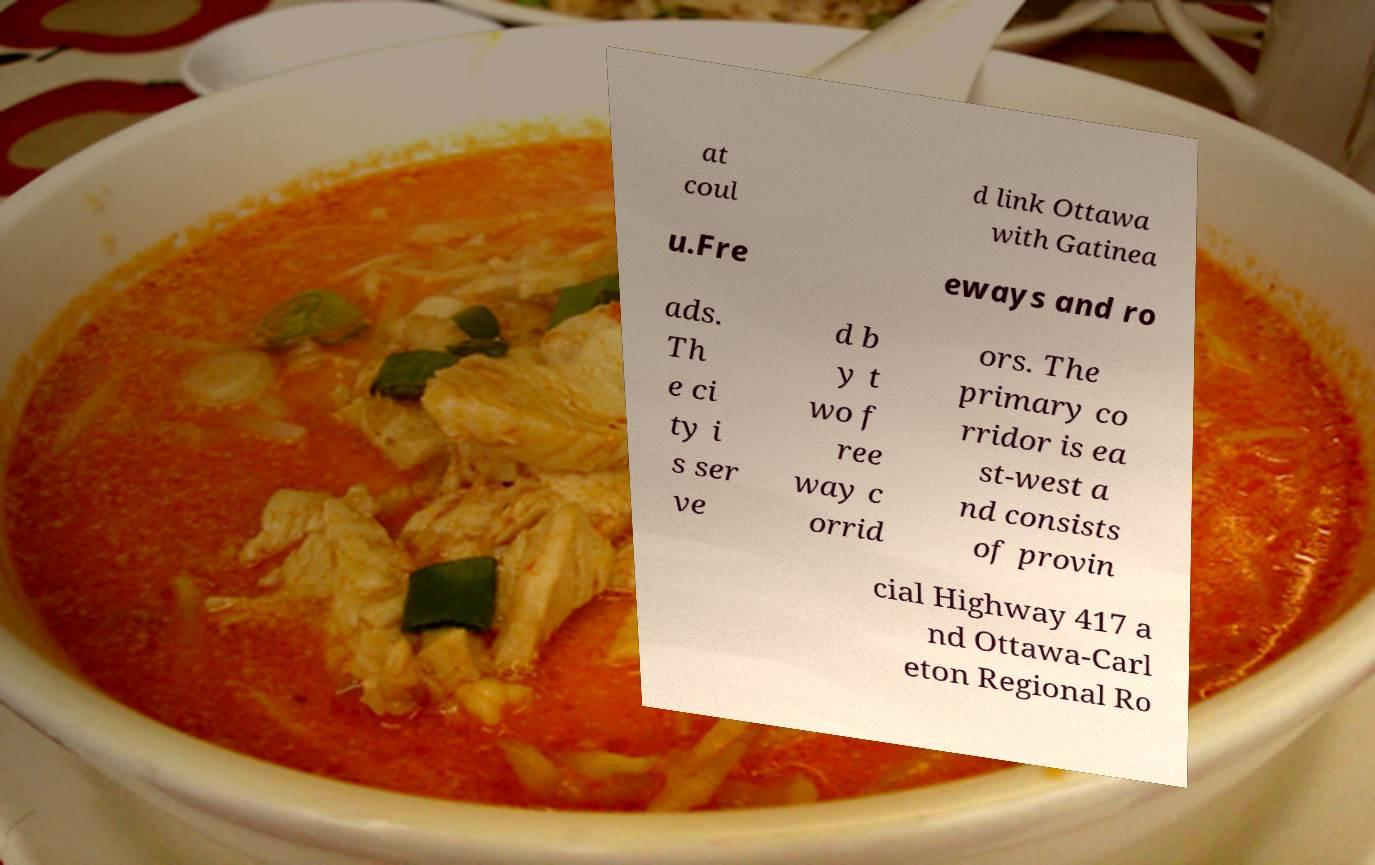What messages or text are displayed in this image? I need them in a readable, typed format. at coul d link Ottawa with Gatinea u.Fre eways and ro ads. Th e ci ty i s ser ve d b y t wo f ree way c orrid ors. The primary co rridor is ea st-west a nd consists of provin cial Highway 417 a nd Ottawa-Carl eton Regional Ro 